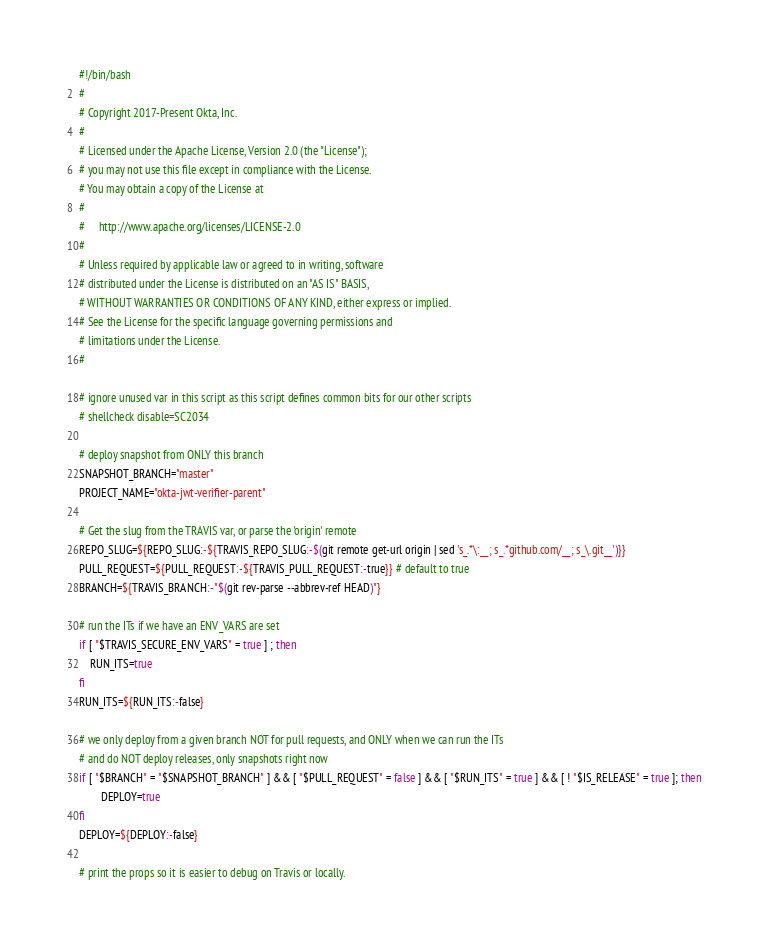<code> <loc_0><loc_0><loc_500><loc_500><_Bash_>#!/bin/bash
#
# Copyright 2017-Present Okta, Inc.
#
# Licensed under the Apache License, Version 2.0 (the "License");
# you may not use this file except in compliance with the License.
# You may obtain a copy of the License at
#
#     http://www.apache.org/licenses/LICENSE-2.0
#
# Unless required by applicable law or agreed to in writing, software
# distributed under the License is distributed on an "AS IS" BASIS,
# WITHOUT WARRANTIES OR CONDITIONS OF ANY KIND, either express or implied.
# See the License for the specific language governing permissions and
# limitations under the License.
#

# ignore unused var in this script as this script defines common bits for our other scripts
# shellcheck disable=SC2034

# deploy snapshot from ONLY this branch
SNAPSHOT_BRANCH="master"
PROJECT_NAME="okta-jwt-verifier-parent"

# Get the slug from the TRAVIS var, or parse the 'origin' remote
REPO_SLUG=${REPO_SLUG:-${TRAVIS_REPO_SLUG:-$(git remote get-url origin | sed 's_.*\:__; s_.*github.com/__; s_\.git__')}}
PULL_REQUEST=${PULL_REQUEST:-${TRAVIS_PULL_REQUEST:-true}} # default to true
BRANCH=${TRAVIS_BRANCH:-"$(git rev-parse --abbrev-ref HEAD)"}

# run the ITs if we have an ENV_VARS are set
if [ "$TRAVIS_SECURE_ENV_VARS" = true ] ; then
    RUN_ITS=true
fi
RUN_ITS=${RUN_ITS:-false}

# we only deploy from a given branch NOT for pull requests, and ONLY when we can run the ITs
# and do NOT deploy releases, only snapshots right now
if [ "$BRANCH" = "$SNAPSHOT_BRANCH" ] && [ "$PULL_REQUEST" = false ] && [ "$RUN_ITS" = true ] && [ ! "$IS_RELEASE" = true ]; then
        DEPLOY=true
fi
DEPLOY=${DEPLOY:-false}

# print the props so it is easier to debug on Travis or locally.</code> 